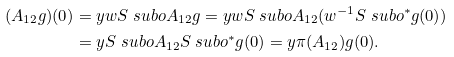<formula> <loc_0><loc_0><loc_500><loc_500>( A _ { 1 2 } g ) ( 0 ) & = y w S _ { \ } s u b o A _ { 1 2 } g = y w S _ { \ } s u b o A _ { 1 2 } ( w ^ { - 1 } S _ { \ } s u b o ^ { * } g ( 0 ) ) \\ & = y S _ { \ } s u b o A _ { 1 2 } S _ { \ } s u b o ^ { * } g ( 0 ) = y \pi ( A _ { 1 2 } ) g ( 0 ) .</formula> 